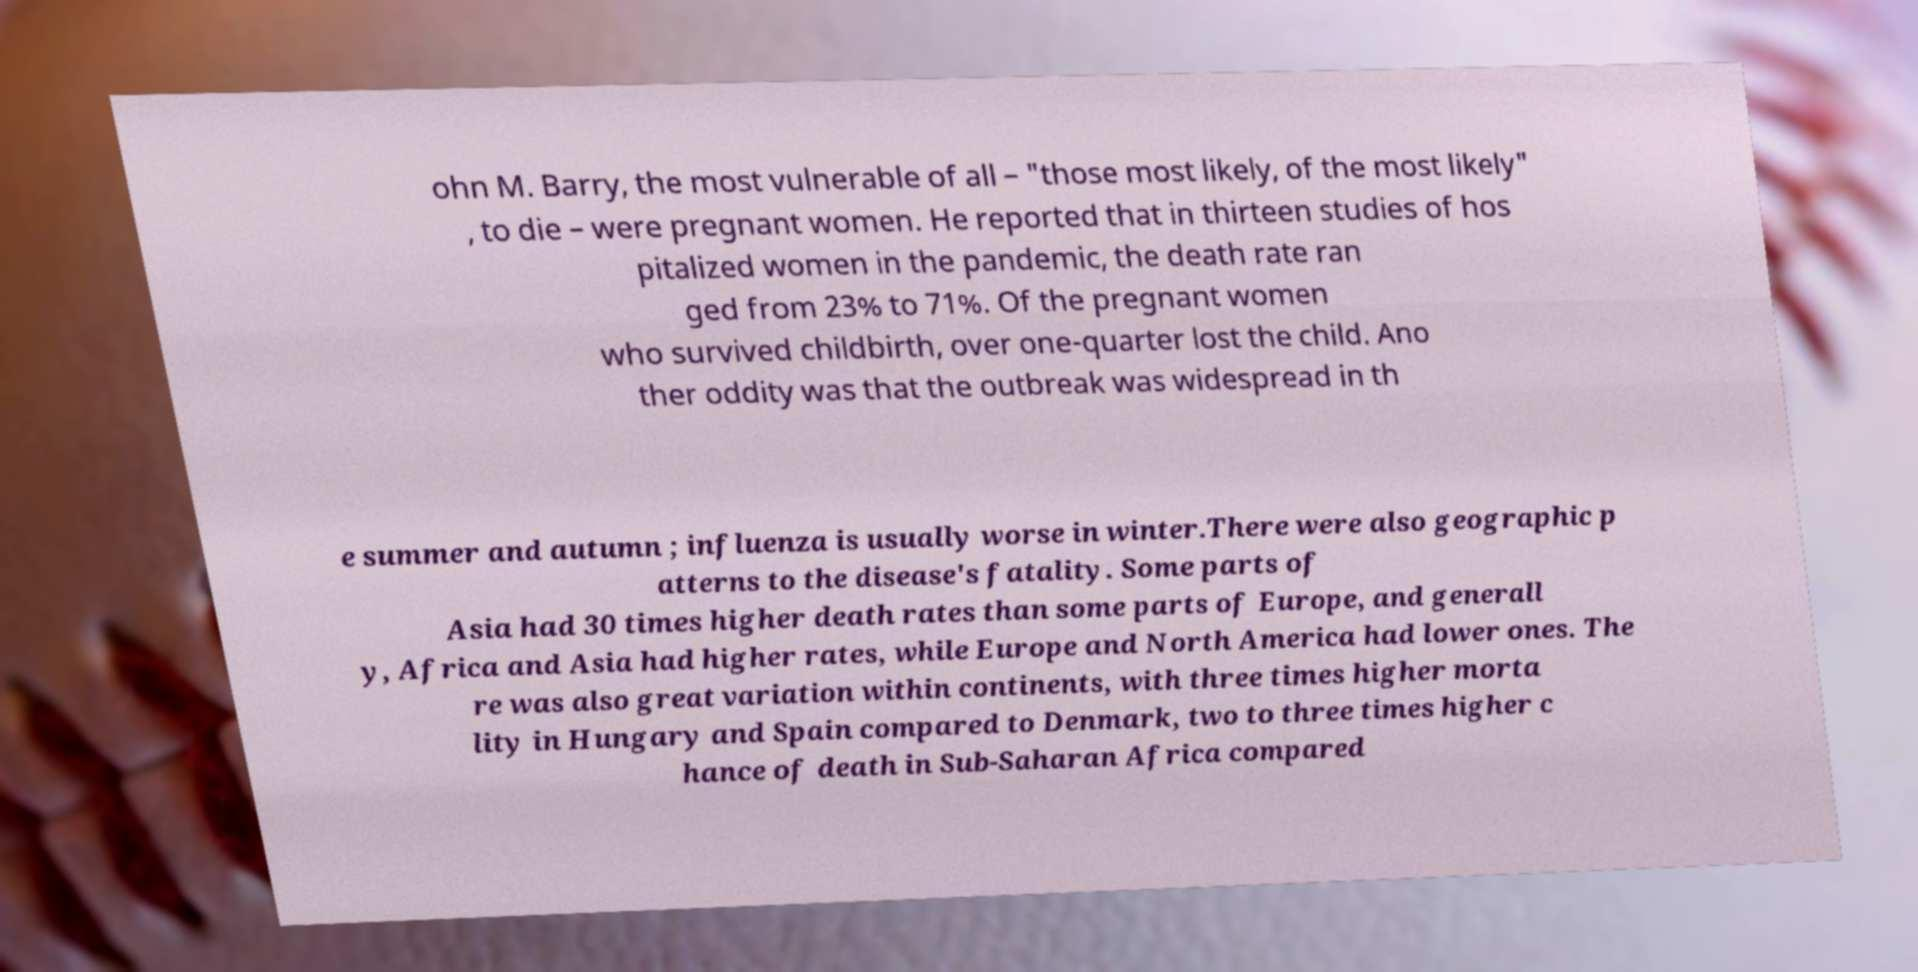Could you extract and type out the text from this image? ohn M. Barry, the most vulnerable of all – "those most likely, of the most likely" , to die – were pregnant women. He reported that in thirteen studies of hos pitalized women in the pandemic, the death rate ran ged from 23% to 71%. Of the pregnant women who survived childbirth, over one-quarter lost the child. Ano ther oddity was that the outbreak was widespread in th e summer and autumn ; influenza is usually worse in winter.There were also geographic p atterns to the disease's fatality. Some parts of Asia had 30 times higher death rates than some parts of Europe, and generall y, Africa and Asia had higher rates, while Europe and North America had lower ones. The re was also great variation within continents, with three times higher morta lity in Hungary and Spain compared to Denmark, two to three times higher c hance of death in Sub-Saharan Africa compared 